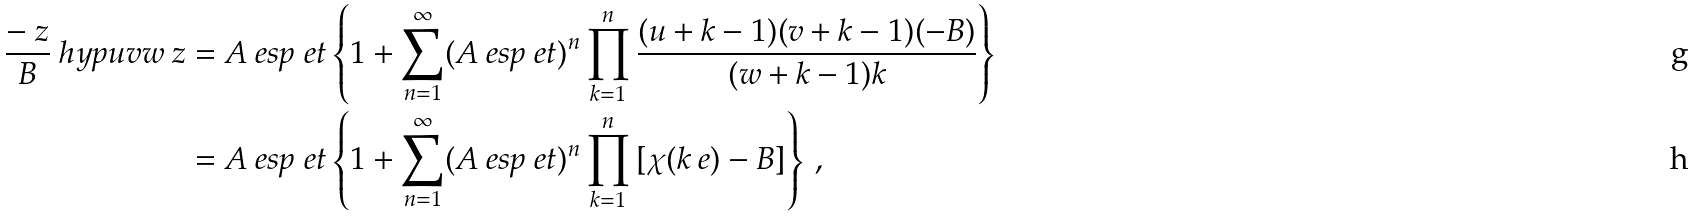Convert formula to latex. <formula><loc_0><loc_0><loc_500><loc_500>\frac { - \ z } { B } \ h y p { u } { v } { w } { \ z } & = A \ e s p { \ e t } \left \{ 1 + \sum _ { n = 1 } ^ { \infty } ( A \ e s p { \ e t } ) ^ { n } \prod _ { k = 1 } ^ { n } \frac { ( u + k - 1 ) ( v + k - 1 ) ( - B ) } { ( w + k - 1 ) k } \right \} \\ & = A \ e s p { \ e t } \left \{ 1 + \sum _ { n = 1 } ^ { \infty } ( A \ e s p { \ e t } ) ^ { n } \prod _ { k = 1 } ^ { n } \left [ \chi ( k \ e ) - B \right ] \right \} \, ,</formula> 